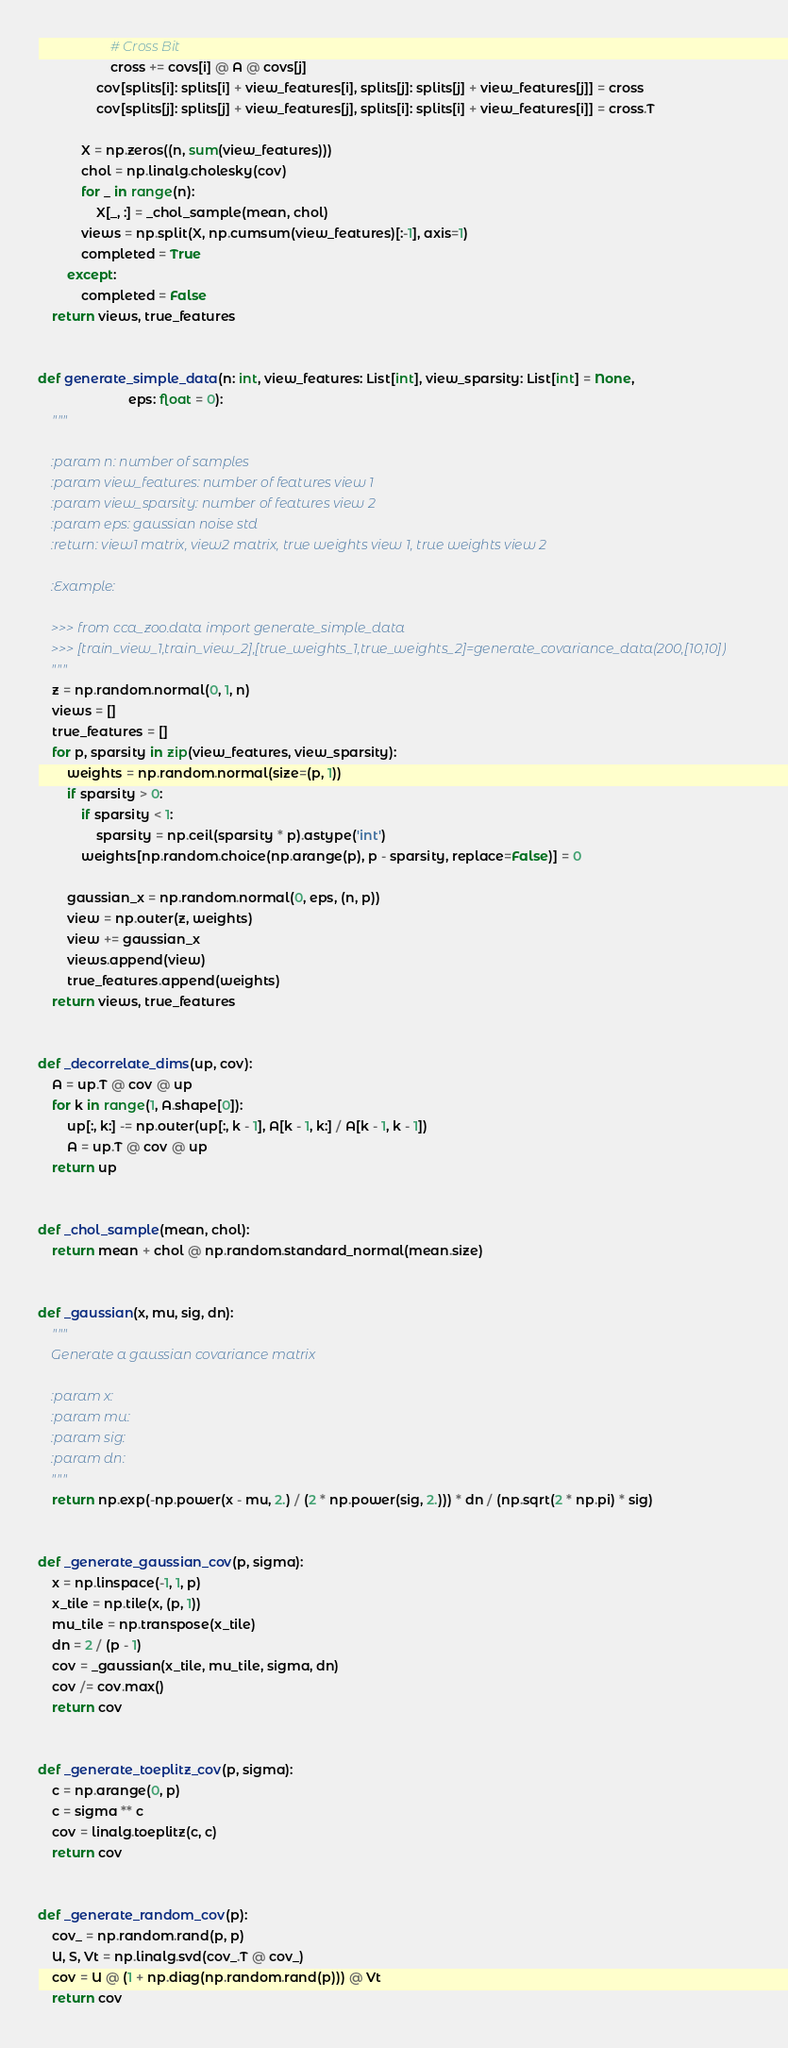Convert code to text. <code><loc_0><loc_0><loc_500><loc_500><_Python_>                    # Cross Bit
                    cross += covs[i] @ A @ covs[j]
                cov[splits[i]: splits[i] + view_features[i], splits[j]: splits[j] + view_features[j]] = cross
                cov[splits[j]: splits[j] + view_features[j], splits[i]: splits[i] + view_features[i]] = cross.T

            X = np.zeros((n, sum(view_features)))
            chol = np.linalg.cholesky(cov)
            for _ in range(n):
                X[_, :] = _chol_sample(mean, chol)
            views = np.split(X, np.cumsum(view_features)[:-1], axis=1)
            completed = True
        except:
            completed = False
    return views, true_features


def generate_simple_data(n: int, view_features: List[int], view_sparsity: List[int] = None,
                         eps: float = 0):
    """

    :param n: number of samples
    :param view_features: number of features view 1
    :param view_sparsity: number of features view 2
    :param eps: gaussian noise std
    :return: view1 matrix, view2 matrix, true weights view 1, true weights view 2

    :Example:

    >>> from cca_zoo.data import generate_simple_data
    >>> [train_view_1,train_view_2],[true_weights_1,true_weights_2]=generate_covariance_data(200,[10,10])
    """
    z = np.random.normal(0, 1, n)
    views = []
    true_features = []
    for p, sparsity in zip(view_features, view_sparsity):
        weights = np.random.normal(size=(p, 1))
        if sparsity > 0:
            if sparsity < 1:
                sparsity = np.ceil(sparsity * p).astype('int')
            weights[np.random.choice(np.arange(p), p - sparsity, replace=False)] = 0

        gaussian_x = np.random.normal(0, eps, (n, p))
        view = np.outer(z, weights)
        view += gaussian_x
        views.append(view)
        true_features.append(weights)
    return views, true_features


def _decorrelate_dims(up, cov):
    A = up.T @ cov @ up
    for k in range(1, A.shape[0]):
        up[:, k:] -= np.outer(up[:, k - 1], A[k - 1, k:] / A[k - 1, k - 1])
        A = up.T @ cov @ up
    return up


def _chol_sample(mean, chol):
    return mean + chol @ np.random.standard_normal(mean.size)


def _gaussian(x, mu, sig, dn):
    """
    Generate a gaussian covariance matrix

    :param x:
    :param mu:
    :param sig:
    :param dn:
    """
    return np.exp(-np.power(x - mu, 2.) / (2 * np.power(sig, 2.))) * dn / (np.sqrt(2 * np.pi) * sig)


def _generate_gaussian_cov(p, sigma):
    x = np.linspace(-1, 1, p)
    x_tile = np.tile(x, (p, 1))
    mu_tile = np.transpose(x_tile)
    dn = 2 / (p - 1)
    cov = _gaussian(x_tile, mu_tile, sigma, dn)
    cov /= cov.max()
    return cov


def _generate_toeplitz_cov(p, sigma):
    c = np.arange(0, p)
    c = sigma ** c
    cov = linalg.toeplitz(c, c)
    return cov


def _generate_random_cov(p):
    cov_ = np.random.rand(p, p)
    U, S, Vt = np.linalg.svd(cov_.T @ cov_)
    cov = U @ (1 + np.diag(np.random.rand(p))) @ Vt
    return cov
</code> 